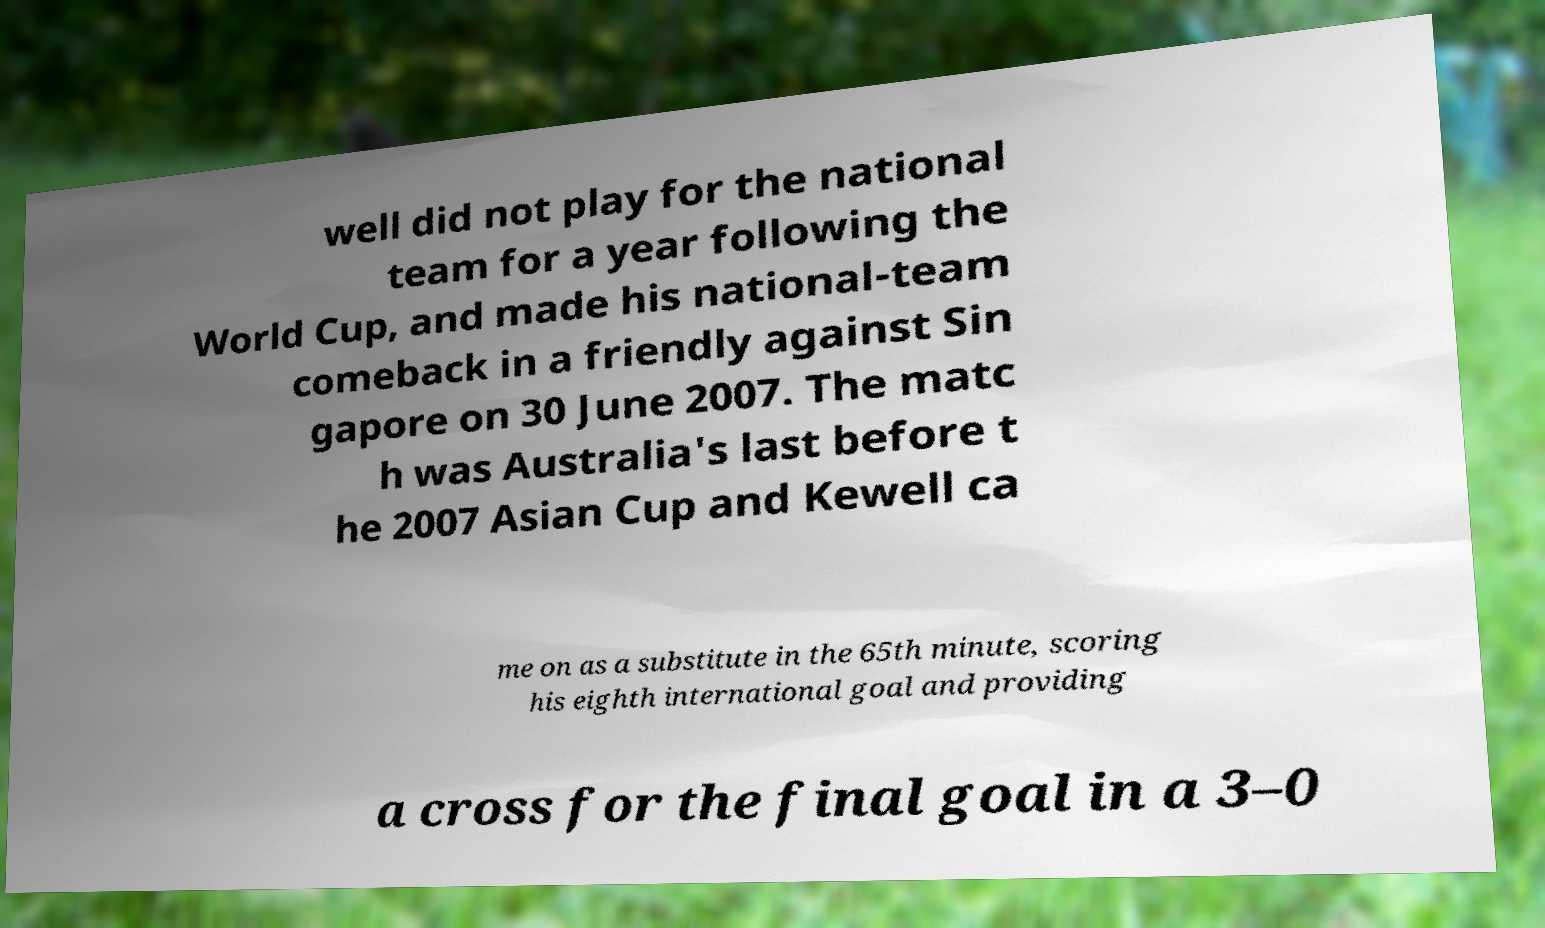Please identify and transcribe the text found in this image. well did not play for the national team for a year following the World Cup, and made his national-team comeback in a friendly against Sin gapore on 30 June 2007. The matc h was Australia's last before t he 2007 Asian Cup and Kewell ca me on as a substitute in the 65th minute, scoring his eighth international goal and providing a cross for the final goal in a 3–0 